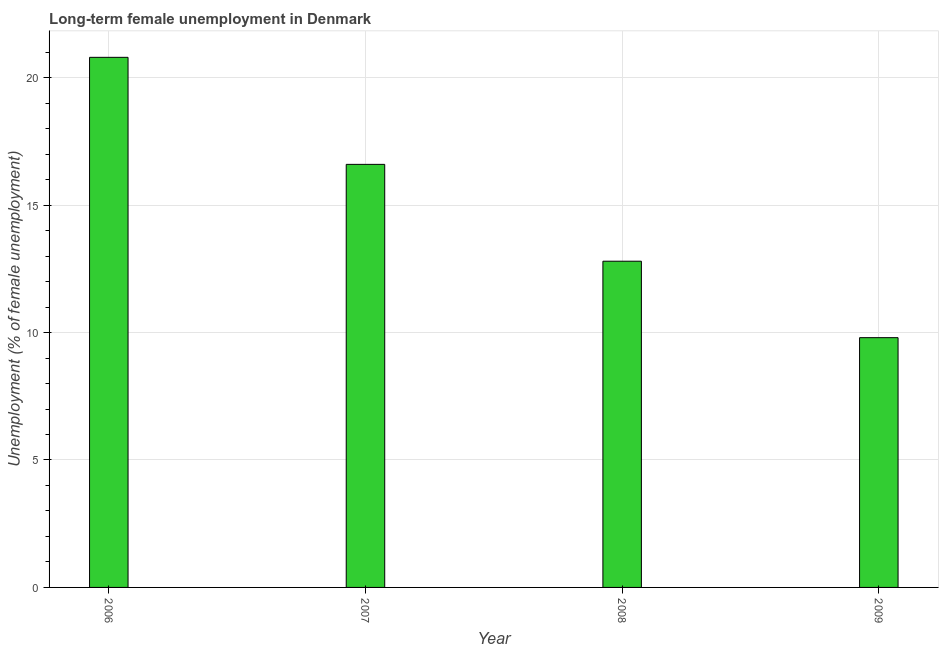Does the graph contain any zero values?
Offer a terse response. No. Does the graph contain grids?
Offer a very short reply. Yes. What is the title of the graph?
Your answer should be compact. Long-term female unemployment in Denmark. What is the label or title of the X-axis?
Your answer should be very brief. Year. What is the label or title of the Y-axis?
Your answer should be compact. Unemployment (% of female unemployment). What is the long-term female unemployment in 2008?
Provide a short and direct response. 12.8. Across all years, what is the maximum long-term female unemployment?
Your answer should be very brief. 20.8. Across all years, what is the minimum long-term female unemployment?
Your response must be concise. 9.8. In which year was the long-term female unemployment maximum?
Ensure brevity in your answer.  2006. What is the sum of the long-term female unemployment?
Offer a terse response. 60. What is the difference between the long-term female unemployment in 2006 and 2008?
Offer a terse response. 8. What is the median long-term female unemployment?
Your response must be concise. 14.7. What is the ratio of the long-term female unemployment in 2008 to that in 2009?
Give a very brief answer. 1.31. Is the difference between the long-term female unemployment in 2006 and 2008 greater than the difference between any two years?
Your response must be concise. No. Is the sum of the long-term female unemployment in 2008 and 2009 greater than the maximum long-term female unemployment across all years?
Your answer should be very brief. Yes. In how many years, is the long-term female unemployment greater than the average long-term female unemployment taken over all years?
Offer a very short reply. 2. Are all the bars in the graph horizontal?
Offer a very short reply. No. How many years are there in the graph?
Give a very brief answer. 4. Are the values on the major ticks of Y-axis written in scientific E-notation?
Your answer should be compact. No. What is the Unemployment (% of female unemployment) of 2006?
Keep it short and to the point. 20.8. What is the Unemployment (% of female unemployment) in 2007?
Offer a terse response. 16.6. What is the Unemployment (% of female unemployment) in 2008?
Ensure brevity in your answer.  12.8. What is the Unemployment (% of female unemployment) of 2009?
Provide a short and direct response. 9.8. What is the difference between the Unemployment (% of female unemployment) in 2006 and 2009?
Offer a very short reply. 11. What is the difference between the Unemployment (% of female unemployment) in 2007 and 2008?
Provide a succinct answer. 3.8. What is the difference between the Unemployment (% of female unemployment) in 2008 and 2009?
Provide a short and direct response. 3. What is the ratio of the Unemployment (% of female unemployment) in 2006 to that in 2007?
Your answer should be very brief. 1.25. What is the ratio of the Unemployment (% of female unemployment) in 2006 to that in 2008?
Offer a very short reply. 1.62. What is the ratio of the Unemployment (% of female unemployment) in 2006 to that in 2009?
Your response must be concise. 2.12. What is the ratio of the Unemployment (% of female unemployment) in 2007 to that in 2008?
Provide a short and direct response. 1.3. What is the ratio of the Unemployment (% of female unemployment) in 2007 to that in 2009?
Offer a terse response. 1.69. What is the ratio of the Unemployment (% of female unemployment) in 2008 to that in 2009?
Make the answer very short. 1.31. 